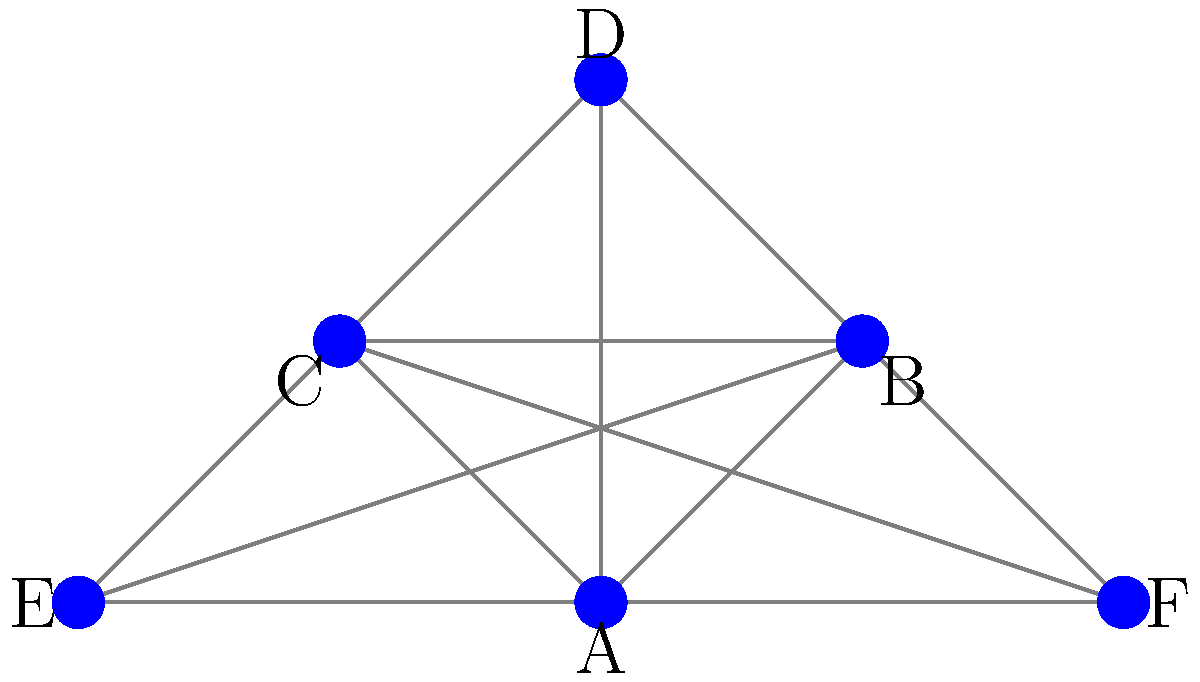In the peer-to-peer network depicted above for sharing traditional Korean music recordings, how many direct connections does node A have to other nodes? To determine the number of direct connections node A has to other nodes in this peer-to-peer network for sharing traditional Korean music recordings, we need to follow these steps:

1. Identify node A in the network diagram. Node A is located at the center of the network.

2. Count the number of edges (lines) directly connecting node A to other nodes:
   - A is connected to B (top right)
   - A is connected to C (top left)
   - A is connected to D (top center)
   - A is connected to E (left)
   - A is connected to F (right)

3. Sum up the total number of direct connections:
   Node A has 5 direct connections to other nodes in the network.

This network structure allows for efficient distribution of traditional Korean music recordings, as node A can directly share files with five other nodes, facilitating rapid dissemination of music throughout the network.
Answer: 5 